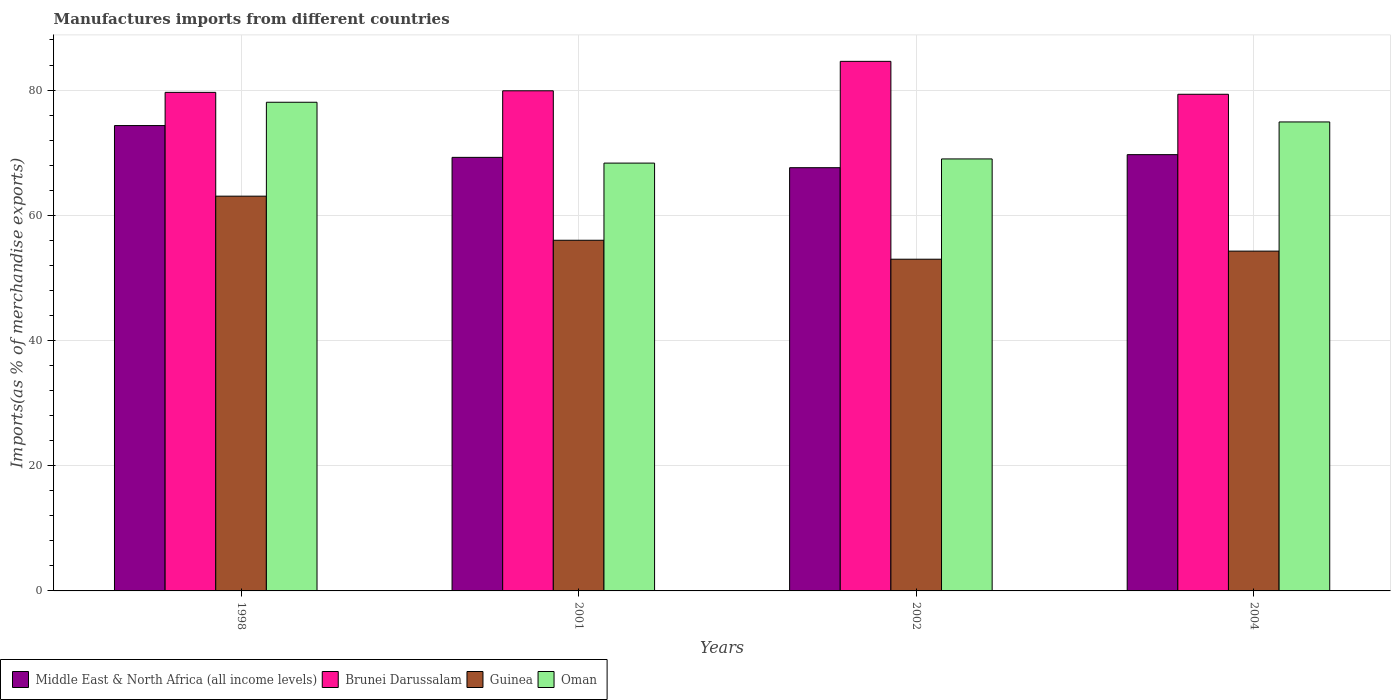How many groups of bars are there?
Offer a terse response. 4. How many bars are there on the 1st tick from the right?
Provide a succinct answer. 4. What is the label of the 4th group of bars from the left?
Your answer should be very brief. 2004. What is the percentage of imports to different countries in Middle East & North Africa (all income levels) in 2004?
Your answer should be very brief. 69.69. Across all years, what is the maximum percentage of imports to different countries in Brunei Darussalam?
Your response must be concise. 84.59. Across all years, what is the minimum percentage of imports to different countries in Middle East & North Africa (all income levels)?
Provide a succinct answer. 67.6. In which year was the percentage of imports to different countries in Middle East & North Africa (all income levels) maximum?
Give a very brief answer. 1998. In which year was the percentage of imports to different countries in Brunei Darussalam minimum?
Make the answer very short. 2004. What is the total percentage of imports to different countries in Brunei Darussalam in the graph?
Give a very brief answer. 323.44. What is the difference between the percentage of imports to different countries in Brunei Darussalam in 1998 and that in 2001?
Make the answer very short. -0.25. What is the difference between the percentage of imports to different countries in Guinea in 2001 and the percentage of imports to different countries in Oman in 2002?
Ensure brevity in your answer.  -12.99. What is the average percentage of imports to different countries in Oman per year?
Ensure brevity in your answer.  72.58. In the year 1998, what is the difference between the percentage of imports to different countries in Middle East & North Africa (all income levels) and percentage of imports to different countries in Guinea?
Offer a very short reply. 11.28. What is the ratio of the percentage of imports to different countries in Brunei Darussalam in 2002 to that in 2004?
Keep it short and to the point. 1.07. Is the percentage of imports to different countries in Guinea in 2002 less than that in 2004?
Provide a short and direct response. Yes. What is the difference between the highest and the second highest percentage of imports to different countries in Oman?
Give a very brief answer. 3.14. What is the difference between the highest and the lowest percentage of imports to different countries in Oman?
Offer a terse response. 9.72. Is it the case that in every year, the sum of the percentage of imports to different countries in Middle East & North Africa (all income levels) and percentage of imports to different countries in Guinea is greater than the sum of percentage of imports to different countries in Brunei Darussalam and percentage of imports to different countries in Oman?
Your answer should be very brief. Yes. What does the 3rd bar from the left in 2004 represents?
Offer a very short reply. Guinea. What does the 4th bar from the right in 2002 represents?
Your answer should be compact. Middle East & North Africa (all income levels). How many bars are there?
Your response must be concise. 16. How many years are there in the graph?
Keep it short and to the point. 4. How are the legend labels stacked?
Your answer should be compact. Horizontal. What is the title of the graph?
Offer a terse response. Manufactures imports from different countries. Does "United Kingdom" appear as one of the legend labels in the graph?
Offer a terse response. No. What is the label or title of the Y-axis?
Your response must be concise. Imports(as % of merchandise exports). What is the Imports(as % of merchandise exports) of Middle East & North Africa (all income levels) in 1998?
Give a very brief answer. 74.33. What is the Imports(as % of merchandise exports) of Brunei Darussalam in 1998?
Provide a short and direct response. 79.63. What is the Imports(as % of merchandise exports) in Guinea in 1998?
Make the answer very short. 63.05. What is the Imports(as % of merchandise exports) in Oman in 1998?
Keep it short and to the point. 78.05. What is the Imports(as % of merchandise exports) in Middle East & North Africa (all income levels) in 2001?
Provide a succinct answer. 69.25. What is the Imports(as % of merchandise exports) of Brunei Darussalam in 2001?
Keep it short and to the point. 79.89. What is the Imports(as % of merchandise exports) of Guinea in 2001?
Offer a terse response. 56.01. What is the Imports(as % of merchandise exports) of Oman in 2001?
Your answer should be compact. 68.34. What is the Imports(as % of merchandise exports) in Middle East & North Africa (all income levels) in 2002?
Give a very brief answer. 67.6. What is the Imports(as % of merchandise exports) in Brunei Darussalam in 2002?
Give a very brief answer. 84.59. What is the Imports(as % of merchandise exports) of Guinea in 2002?
Your answer should be very brief. 52.98. What is the Imports(as % of merchandise exports) in Oman in 2002?
Make the answer very short. 69. What is the Imports(as % of merchandise exports) in Middle East & North Africa (all income levels) in 2004?
Your answer should be compact. 69.69. What is the Imports(as % of merchandise exports) in Brunei Darussalam in 2004?
Give a very brief answer. 79.33. What is the Imports(as % of merchandise exports) in Guinea in 2004?
Provide a short and direct response. 54.28. What is the Imports(as % of merchandise exports) in Oman in 2004?
Your response must be concise. 74.91. Across all years, what is the maximum Imports(as % of merchandise exports) of Middle East & North Africa (all income levels)?
Make the answer very short. 74.33. Across all years, what is the maximum Imports(as % of merchandise exports) of Brunei Darussalam?
Your answer should be very brief. 84.59. Across all years, what is the maximum Imports(as % of merchandise exports) of Guinea?
Your response must be concise. 63.05. Across all years, what is the maximum Imports(as % of merchandise exports) of Oman?
Your answer should be very brief. 78.05. Across all years, what is the minimum Imports(as % of merchandise exports) of Middle East & North Africa (all income levels)?
Offer a terse response. 67.6. Across all years, what is the minimum Imports(as % of merchandise exports) in Brunei Darussalam?
Offer a very short reply. 79.33. Across all years, what is the minimum Imports(as % of merchandise exports) of Guinea?
Your answer should be compact. 52.98. Across all years, what is the minimum Imports(as % of merchandise exports) in Oman?
Ensure brevity in your answer.  68.34. What is the total Imports(as % of merchandise exports) in Middle East & North Africa (all income levels) in the graph?
Offer a terse response. 280.87. What is the total Imports(as % of merchandise exports) in Brunei Darussalam in the graph?
Provide a succinct answer. 323.44. What is the total Imports(as % of merchandise exports) of Guinea in the graph?
Offer a terse response. 226.33. What is the total Imports(as % of merchandise exports) of Oman in the graph?
Give a very brief answer. 290.3. What is the difference between the Imports(as % of merchandise exports) of Middle East & North Africa (all income levels) in 1998 and that in 2001?
Your response must be concise. 5.08. What is the difference between the Imports(as % of merchandise exports) in Brunei Darussalam in 1998 and that in 2001?
Your answer should be very brief. -0.25. What is the difference between the Imports(as % of merchandise exports) of Guinea in 1998 and that in 2001?
Make the answer very short. 7.04. What is the difference between the Imports(as % of merchandise exports) of Oman in 1998 and that in 2001?
Give a very brief answer. 9.72. What is the difference between the Imports(as % of merchandise exports) of Middle East & North Africa (all income levels) in 1998 and that in 2002?
Provide a succinct answer. 6.73. What is the difference between the Imports(as % of merchandise exports) of Brunei Darussalam in 1998 and that in 2002?
Your answer should be very brief. -4.96. What is the difference between the Imports(as % of merchandise exports) of Guinea in 1998 and that in 2002?
Offer a very short reply. 10.07. What is the difference between the Imports(as % of merchandise exports) of Oman in 1998 and that in 2002?
Keep it short and to the point. 9.05. What is the difference between the Imports(as % of merchandise exports) of Middle East & North Africa (all income levels) in 1998 and that in 2004?
Offer a terse response. 4.64. What is the difference between the Imports(as % of merchandise exports) in Brunei Darussalam in 1998 and that in 2004?
Keep it short and to the point. 0.3. What is the difference between the Imports(as % of merchandise exports) of Guinea in 1998 and that in 2004?
Offer a terse response. 8.78. What is the difference between the Imports(as % of merchandise exports) in Oman in 1998 and that in 2004?
Your answer should be compact. 3.14. What is the difference between the Imports(as % of merchandise exports) in Middle East & North Africa (all income levels) in 2001 and that in 2002?
Your answer should be compact. 1.65. What is the difference between the Imports(as % of merchandise exports) in Brunei Darussalam in 2001 and that in 2002?
Your answer should be compact. -4.7. What is the difference between the Imports(as % of merchandise exports) of Guinea in 2001 and that in 2002?
Your response must be concise. 3.03. What is the difference between the Imports(as % of merchandise exports) of Oman in 2001 and that in 2002?
Keep it short and to the point. -0.67. What is the difference between the Imports(as % of merchandise exports) of Middle East & North Africa (all income levels) in 2001 and that in 2004?
Provide a short and direct response. -0.43. What is the difference between the Imports(as % of merchandise exports) in Brunei Darussalam in 2001 and that in 2004?
Offer a very short reply. 0.56. What is the difference between the Imports(as % of merchandise exports) in Guinea in 2001 and that in 2004?
Provide a succinct answer. 1.73. What is the difference between the Imports(as % of merchandise exports) in Oman in 2001 and that in 2004?
Ensure brevity in your answer.  -6.57. What is the difference between the Imports(as % of merchandise exports) of Middle East & North Africa (all income levels) in 2002 and that in 2004?
Give a very brief answer. -2.08. What is the difference between the Imports(as % of merchandise exports) in Brunei Darussalam in 2002 and that in 2004?
Make the answer very short. 5.26. What is the difference between the Imports(as % of merchandise exports) of Guinea in 2002 and that in 2004?
Offer a very short reply. -1.29. What is the difference between the Imports(as % of merchandise exports) of Oman in 2002 and that in 2004?
Make the answer very short. -5.91. What is the difference between the Imports(as % of merchandise exports) in Middle East & North Africa (all income levels) in 1998 and the Imports(as % of merchandise exports) in Brunei Darussalam in 2001?
Give a very brief answer. -5.56. What is the difference between the Imports(as % of merchandise exports) of Middle East & North Africa (all income levels) in 1998 and the Imports(as % of merchandise exports) of Guinea in 2001?
Offer a very short reply. 18.32. What is the difference between the Imports(as % of merchandise exports) in Middle East & North Africa (all income levels) in 1998 and the Imports(as % of merchandise exports) in Oman in 2001?
Ensure brevity in your answer.  5.99. What is the difference between the Imports(as % of merchandise exports) in Brunei Darussalam in 1998 and the Imports(as % of merchandise exports) in Guinea in 2001?
Give a very brief answer. 23.62. What is the difference between the Imports(as % of merchandise exports) of Brunei Darussalam in 1998 and the Imports(as % of merchandise exports) of Oman in 2001?
Offer a very short reply. 11.3. What is the difference between the Imports(as % of merchandise exports) of Guinea in 1998 and the Imports(as % of merchandise exports) of Oman in 2001?
Your answer should be compact. -5.28. What is the difference between the Imports(as % of merchandise exports) of Middle East & North Africa (all income levels) in 1998 and the Imports(as % of merchandise exports) of Brunei Darussalam in 2002?
Make the answer very short. -10.26. What is the difference between the Imports(as % of merchandise exports) of Middle East & North Africa (all income levels) in 1998 and the Imports(as % of merchandise exports) of Guinea in 2002?
Keep it short and to the point. 21.35. What is the difference between the Imports(as % of merchandise exports) in Middle East & North Africa (all income levels) in 1998 and the Imports(as % of merchandise exports) in Oman in 2002?
Provide a succinct answer. 5.33. What is the difference between the Imports(as % of merchandise exports) of Brunei Darussalam in 1998 and the Imports(as % of merchandise exports) of Guinea in 2002?
Provide a succinct answer. 26.65. What is the difference between the Imports(as % of merchandise exports) in Brunei Darussalam in 1998 and the Imports(as % of merchandise exports) in Oman in 2002?
Provide a short and direct response. 10.63. What is the difference between the Imports(as % of merchandise exports) of Guinea in 1998 and the Imports(as % of merchandise exports) of Oman in 2002?
Your answer should be compact. -5.95. What is the difference between the Imports(as % of merchandise exports) of Middle East & North Africa (all income levels) in 1998 and the Imports(as % of merchandise exports) of Brunei Darussalam in 2004?
Give a very brief answer. -5. What is the difference between the Imports(as % of merchandise exports) in Middle East & North Africa (all income levels) in 1998 and the Imports(as % of merchandise exports) in Guinea in 2004?
Provide a succinct answer. 20.05. What is the difference between the Imports(as % of merchandise exports) in Middle East & North Africa (all income levels) in 1998 and the Imports(as % of merchandise exports) in Oman in 2004?
Provide a short and direct response. -0.58. What is the difference between the Imports(as % of merchandise exports) in Brunei Darussalam in 1998 and the Imports(as % of merchandise exports) in Guinea in 2004?
Ensure brevity in your answer.  25.36. What is the difference between the Imports(as % of merchandise exports) of Brunei Darussalam in 1998 and the Imports(as % of merchandise exports) of Oman in 2004?
Your answer should be compact. 4.72. What is the difference between the Imports(as % of merchandise exports) of Guinea in 1998 and the Imports(as % of merchandise exports) of Oman in 2004?
Your response must be concise. -11.86. What is the difference between the Imports(as % of merchandise exports) of Middle East & North Africa (all income levels) in 2001 and the Imports(as % of merchandise exports) of Brunei Darussalam in 2002?
Keep it short and to the point. -15.34. What is the difference between the Imports(as % of merchandise exports) of Middle East & North Africa (all income levels) in 2001 and the Imports(as % of merchandise exports) of Guinea in 2002?
Provide a succinct answer. 16.27. What is the difference between the Imports(as % of merchandise exports) in Middle East & North Africa (all income levels) in 2001 and the Imports(as % of merchandise exports) in Oman in 2002?
Provide a succinct answer. 0.25. What is the difference between the Imports(as % of merchandise exports) in Brunei Darussalam in 2001 and the Imports(as % of merchandise exports) in Guinea in 2002?
Make the answer very short. 26.9. What is the difference between the Imports(as % of merchandise exports) of Brunei Darussalam in 2001 and the Imports(as % of merchandise exports) of Oman in 2002?
Provide a succinct answer. 10.89. What is the difference between the Imports(as % of merchandise exports) in Guinea in 2001 and the Imports(as % of merchandise exports) in Oman in 2002?
Offer a very short reply. -12.99. What is the difference between the Imports(as % of merchandise exports) in Middle East & North Africa (all income levels) in 2001 and the Imports(as % of merchandise exports) in Brunei Darussalam in 2004?
Provide a succinct answer. -10.08. What is the difference between the Imports(as % of merchandise exports) in Middle East & North Africa (all income levels) in 2001 and the Imports(as % of merchandise exports) in Guinea in 2004?
Provide a short and direct response. 14.97. What is the difference between the Imports(as % of merchandise exports) of Middle East & North Africa (all income levels) in 2001 and the Imports(as % of merchandise exports) of Oman in 2004?
Offer a terse response. -5.66. What is the difference between the Imports(as % of merchandise exports) of Brunei Darussalam in 2001 and the Imports(as % of merchandise exports) of Guinea in 2004?
Provide a succinct answer. 25.61. What is the difference between the Imports(as % of merchandise exports) in Brunei Darussalam in 2001 and the Imports(as % of merchandise exports) in Oman in 2004?
Provide a short and direct response. 4.98. What is the difference between the Imports(as % of merchandise exports) in Guinea in 2001 and the Imports(as % of merchandise exports) in Oman in 2004?
Make the answer very short. -18.9. What is the difference between the Imports(as % of merchandise exports) in Middle East & North Africa (all income levels) in 2002 and the Imports(as % of merchandise exports) in Brunei Darussalam in 2004?
Your answer should be compact. -11.73. What is the difference between the Imports(as % of merchandise exports) in Middle East & North Africa (all income levels) in 2002 and the Imports(as % of merchandise exports) in Guinea in 2004?
Keep it short and to the point. 13.32. What is the difference between the Imports(as % of merchandise exports) in Middle East & North Africa (all income levels) in 2002 and the Imports(as % of merchandise exports) in Oman in 2004?
Your answer should be very brief. -7.31. What is the difference between the Imports(as % of merchandise exports) in Brunei Darussalam in 2002 and the Imports(as % of merchandise exports) in Guinea in 2004?
Provide a succinct answer. 30.31. What is the difference between the Imports(as % of merchandise exports) in Brunei Darussalam in 2002 and the Imports(as % of merchandise exports) in Oman in 2004?
Offer a very short reply. 9.68. What is the difference between the Imports(as % of merchandise exports) of Guinea in 2002 and the Imports(as % of merchandise exports) of Oman in 2004?
Provide a succinct answer. -21.93. What is the average Imports(as % of merchandise exports) of Middle East & North Africa (all income levels) per year?
Your answer should be very brief. 70.22. What is the average Imports(as % of merchandise exports) of Brunei Darussalam per year?
Keep it short and to the point. 80.86. What is the average Imports(as % of merchandise exports) of Guinea per year?
Offer a very short reply. 56.58. What is the average Imports(as % of merchandise exports) in Oman per year?
Provide a short and direct response. 72.58. In the year 1998, what is the difference between the Imports(as % of merchandise exports) of Middle East & North Africa (all income levels) and Imports(as % of merchandise exports) of Brunei Darussalam?
Offer a very short reply. -5.3. In the year 1998, what is the difference between the Imports(as % of merchandise exports) in Middle East & North Africa (all income levels) and Imports(as % of merchandise exports) in Guinea?
Ensure brevity in your answer.  11.28. In the year 1998, what is the difference between the Imports(as % of merchandise exports) in Middle East & North Africa (all income levels) and Imports(as % of merchandise exports) in Oman?
Your response must be concise. -3.72. In the year 1998, what is the difference between the Imports(as % of merchandise exports) in Brunei Darussalam and Imports(as % of merchandise exports) in Guinea?
Your answer should be compact. 16.58. In the year 1998, what is the difference between the Imports(as % of merchandise exports) of Brunei Darussalam and Imports(as % of merchandise exports) of Oman?
Offer a very short reply. 1.58. In the year 1998, what is the difference between the Imports(as % of merchandise exports) in Guinea and Imports(as % of merchandise exports) in Oman?
Give a very brief answer. -15. In the year 2001, what is the difference between the Imports(as % of merchandise exports) in Middle East & North Africa (all income levels) and Imports(as % of merchandise exports) in Brunei Darussalam?
Your answer should be very brief. -10.64. In the year 2001, what is the difference between the Imports(as % of merchandise exports) of Middle East & North Africa (all income levels) and Imports(as % of merchandise exports) of Guinea?
Keep it short and to the point. 13.24. In the year 2001, what is the difference between the Imports(as % of merchandise exports) of Middle East & North Africa (all income levels) and Imports(as % of merchandise exports) of Oman?
Provide a succinct answer. 0.92. In the year 2001, what is the difference between the Imports(as % of merchandise exports) of Brunei Darussalam and Imports(as % of merchandise exports) of Guinea?
Provide a succinct answer. 23.87. In the year 2001, what is the difference between the Imports(as % of merchandise exports) of Brunei Darussalam and Imports(as % of merchandise exports) of Oman?
Your response must be concise. 11.55. In the year 2001, what is the difference between the Imports(as % of merchandise exports) in Guinea and Imports(as % of merchandise exports) in Oman?
Ensure brevity in your answer.  -12.32. In the year 2002, what is the difference between the Imports(as % of merchandise exports) in Middle East & North Africa (all income levels) and Imports(as % of merchandise exports) in Brunei Darussalam?
Offer a very short reply. -16.99. In the year 2002, what is the difference between the Imports(as % of merchandise exports) in Middle East & North Africa (all income levels) and Imports(as % of merchandise exports) in Guinea?
Offer a terse response. 14.62. In the year 2002, what is the difference between the Imports(as % of merchandise exports) in Middle East & North Africa (all income levels) and Imports(as % of merchandise exports) in Oman?
Ensure brevity in your answer.  -1.4. In the year 2002, what is the difference between the Imports(as % of merchandise exports) in Brunei Darussalam and Imports(as % of merchandise exports) in Guinea?
Provide a succinct answer. 31.6. In the year 2002, what is the difference between the Imports(as % of merchandise exports) of Brunei Darussalam and Imports(as % of merchandise exports) of Oman?
Keep it short and to the point. 15.59. In the year 2002, what is the difference between the Imports(as % of merchandise exports) of Guinea and Imports(as % of merchandise exports) of Oman?
Offer a terse response. -16.02. In the year 2004, what is the difference between the Imports(as % of merchandise exports) of Middle East & North Africa (all income levels) and Imports(as % of merchandise exports) of Brunei Darussalam?
Your answer should be very brief. -9.64. In the year 2004, what is the difference between the Imports(as % of merchandise exports) in Middle East & North Africa (all income levels) and Imports(as % of merchandise exports) in Guinea?
Keep it short and to the point. 15.41. In the year 2004, what is the difference between the Imports(as % of merchandise exports) in Middle East & North Africa (all income levels) and Imports(as % of merchandise exports) in Oman?
Your answer should be compact. -5.22. In the year 2004, what is the difference between the Imports(as % of merchandise exports) in Brunei Darussalam and Imports(as % of merchandise exports) in Guinea?
Your response must be concise. 25.05. In the year 2004, what is the difference between the Imports(as % of merchandise exports) in Brunei Darussalam and Imports(as % of merchandise exports) in Oman?
Offer a terse response. 4.42. In the year 2004, what is the difference between the Imports(as % of merchandise exports) in Guinea and Imports(as % of merchandise exports) in Oman?
Your response must be concise. -20.63. What is the ratio of the Imports(as % of merchandise exports) in Middle East & North Africa (all income levels) in 1998 to that in 2001?
Your response must be concise. 1.07. What is the ratio of the Imports(as % of merchandise exports) of Brunei Darussalam in 1998 to that in 2001?
Your response must be concise. 1. What is the ratio of the Imports(as % of merchandise exports) in Guinea in 1998 to that in 2001?
Offer a very short reply. 1.13. What is the ratio of the Imports(as % of merchandise exports) of Oman in 1998 to that in 2001?
Your answer should be very brief. 1.14. What is the ratio of the Imports(as % of merchandise exports) in Middle East & North Africa (all income levels) in 1998 to that in 2002?
Give a very brief answer. 1.1. What is the ratio of the Imports(as % of merchandise exports) of Brunei Darussalam in 1998 to that in 2002?
Give a very brief answer. 0.94. What is the ratio of the Imports(as % of merchandise exports) of Guinea in 1998 to that in 2002?
Offer a terse response. 1.19. What is the ratio of the Imports(as % of merchandise exports) in Oman in 1998 to that in 2002?
Your answer should be compact. 1.13. What is the ratio of the Imports(as % of merchandise exports) of Middle East & North Africa (all income levels) in 1998 to that in 2004?
Keep it short and to the point. 1.07. What is the ratio of the Imports(as % of merchandise exports) of Brunei Darussalam in 1998 to that in 2004?
Your answer should be compact. 1. What is the ratio of the Imports(as % of merchandise exports) of Guinea in 1998 to that in 2004?
Keep it short and to the point. 1.16. What is the ratio of the Imports(as % of merchandise exports) in Oman in 1998 to that in 2004?
Give a very brief answer. 1.04. What is the ratio of the Imports(as % of merchandise exports) in Middle East & North Africa (all income levels) in 2001 to that in 2002?
Keep it short and to the point. 1.02. What is the ratio of the Imports(as % of merchandise exports) of Brunei Darussalam in 2001 to that in 2002?
Provide a short and direct response. 0.94. What is the ratio of the Imports(as % of merchandise exports) in Guinea in 2001 to that in 2002?
Your answer should be compact. 1.06. What is the ratio of the Imports(as % of merchandise exports) of Oman in 2001 to that in 2002?
Give a very brief answer. 0.99. What is the ratio of the Imports(as % of merchandise exports) of Brunei Darussalam in 2001 to that in 2004?
Give a very brief answer. 1.01. What is the ratio of the Imports(as % of merchandise exports) in Guinea in 2001 to that in 2004?
Provide a short and direct response. 1.03. What is the ratio of the Imports(as % of merchandise exports) in Oman in 2001 to that in 2004?
Offer a terse response. 0.91. What is the ratio of the Imports(as % of merchandise exports) in Middle East & North Africa (all income levels) in 2002 to that in 2004?
Provide a succinct answer. 0.97. What is the ratio of the Imports(as % of merchandise exports) of Brunei Darussalam in 2002 to that in 2004?
Your answer should be very brief. 1.07. What is the ratio of the Imports(as % of merchandise exports) in Guinea in 2002 to that in 2004?
Give a very brief answer. 0.98. What is the ratio of the Imports(as % of merchandise exports) in Oman in 2002 to that in 2004?
Offer a very short reply. 0.92. What is the difference between the highest and the second highest Imports(as % of merchandise exports) in Middle East & North Africa (all income levels)?
Your answer should be compact. 4.64. What is the difference between the highest and the second highest Imports(as % of merchandise exports) of Brunei Darussalam?
Provide a short and direct response. 4.7. What is the difference between the highest and the second highest Imports(as % of merchandise exports) in Guinea?
Ensure brevity in your answer.  7.04. What is the difference between the highest and the second highest Imports(as % of merchandise exports) of Oman?
Provide a short and direct response. 3.14. What is the difference between the highest and the lowest Imports(as % of merchandise exports) in Middle East & North Africa (all income levels)?
Give a very brief answer. 6.73. What is the difference between the highest and the lowest Imports(as % of merchandise exports) in Brunei Darussalam?
Your answer should be very brief. 5.26. What is the difference between the highest and the lowest Imports(as % of merchandise exports) of Guinea?
Ensure brevity in your answer.  10.07. What is the difference between the highest and the lowest Imports(as % of merchandise exports) of Oman?
Your answer should be compact. 9.72. 